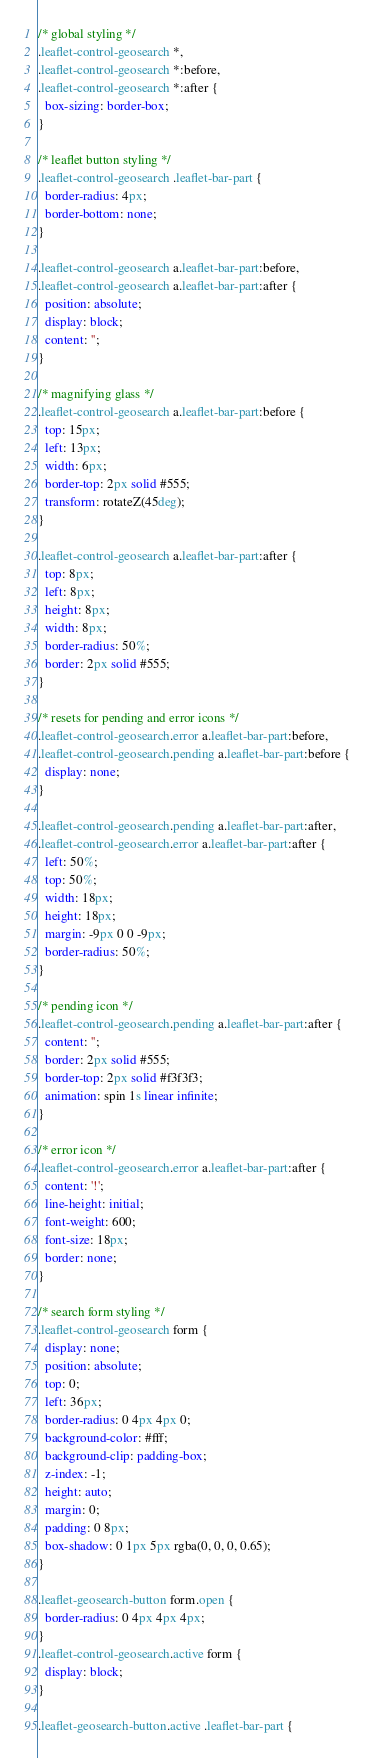<code> <loc_0><loc_0><loc_500><loc_500><_CSS_>/* global styling */
.leaflet-control-geosearch *,
.leaflet-control-geosearch *:before,
.leaflet-control-geosearch *:after {
  box-sizing: border-box;
}

/* leaflet button styling */
.leaflet-control-geosearch .leaflet-bar-part {
  border-radius: 4px;
  border-bottom: none;
}

.leaflet-control-geosearch a.leaflet-bar-part:before,
.leaflet-control-geosearch a.leaflet-bar-part:after {
  position: absolute;
  display: block;
  content: '';
}

/* magnifying glass */
.leaflet-control-geosearch a.leaflet-bar-part:before {
  top: 15px;
  left: 13px;
  width: 6px;
  border-top: 2px solid #555;
  transform: rotateZ(45deg);
}

.leaflet-control-geosearch a.leaflet-bar-part:after {
  top: 8px;
  left: 8px;
  height: 8px;
  width: 8px;
  border-radius: 50%;
  border: 2px solid #555;
}

/* resets for pending and error icons */
.leaflet-control-geosearch.error a.leaflet-bar-part:before,
.leaflet-control-geosearch.pending a.leaflet-bar-part:before {
  display: none;
}

.leaflet-control-geosearch.pending a.leaflet-bar-part:after,
.leaflet-control-geosearch.error a.leaflet-bar-part:after {
  left: 50%;
  top: 50%;
  width: 18px;
  height: 18px;
  margin: -9px 0 0 -9px;
  border-radius: 50%;
}

/* pending icon */
.leaflet-control-geosearch.pending a.leaflet-bar-part:after {
  content: '';
  border: 2px solid #555;
  border-top: 2px solid #f3f3f3;
  animation: spin 1s linear infinite;
}

/* error icon */
.leaflet-control-geosearch.error a.leaflet-bar-part:after {
  content: '!';
  line-height: initial;
  font-weight: 600;
  font-size: 18px;
  border: none;
}

/* search form styling */
.leaflet-control-geosearch form {
  display: none;
  position: absolute;
  top: 0;
  left: 36px;
  border-radius: 0 4px 4px 0;
  background-color: #fff;
  background-clip: padding-box;
  z-index: -1;
  height: auto;
  margin: 0;
  padding: 0 8px;
  box-shadow: 0 1px 5px rgba(0, 0, 0, 0.65);
}

.leaflet-geosearch-button form.open {
  border-radius: 0 4px 4px 4px;
}
.leaflet-control-geosearch.active form {
  display: block;
}

.leaflet-geosearch-button.active .leaflet-bar-part {</code> 